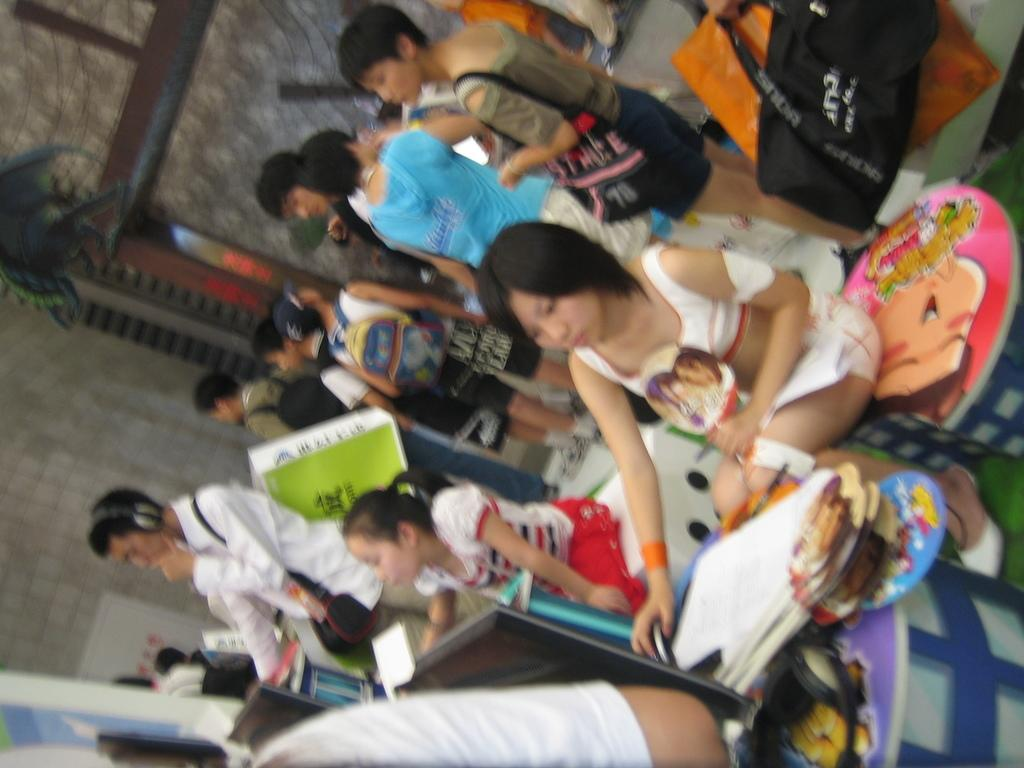Where was the image taken? The image was taken inside a room. How many people are visible in the image? There are many people in the image. What type of furniture is present in the room? There are chairs in the image. What is the primary piece of equipment visible in the image? There is a desktop in the image. What other objects can be seen in the room? There are various objects in the image. What can be seen on the left side of the image? There is a wall visible towards the left side of the image. Can you see a donkey wearing a yoke in the image? No, there is no donkey or yoke present in the image. What is the roll of the objects on the desktop in the image? The provided facts do not specify the roll of the objects on the desktop, so we cannot answer that question definitively. 